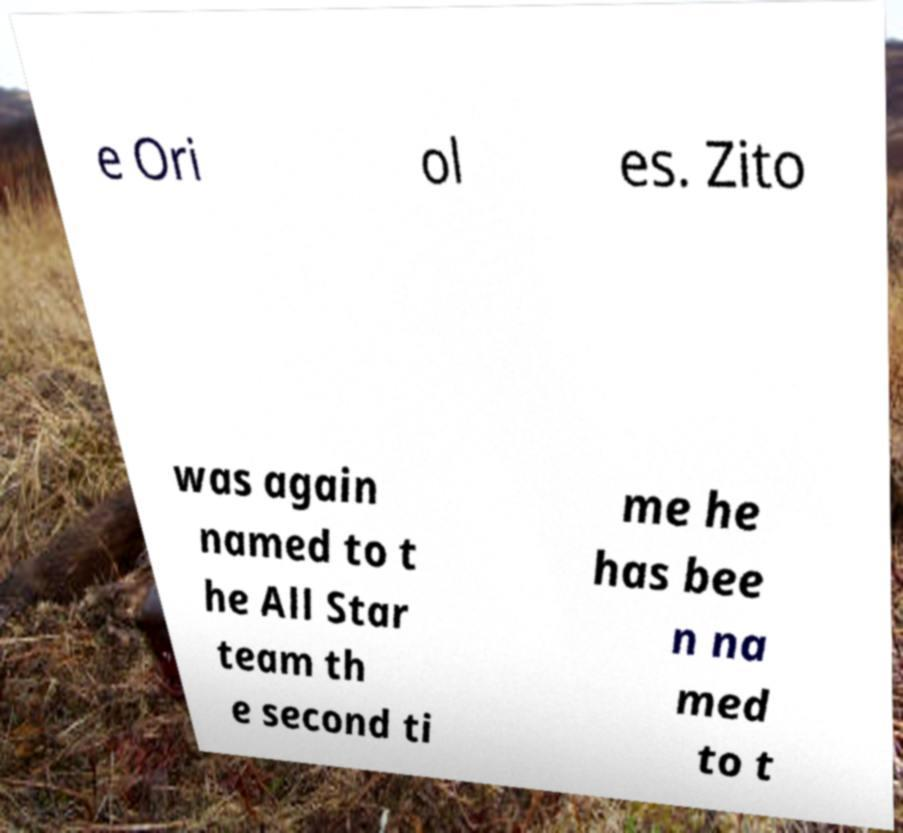There's text embedded in this image that I need extracted. Can you transcribe it verbatim? e Ori ol es. Zito was again named to t he All Star team th e second ti me he has bee n na med to t 